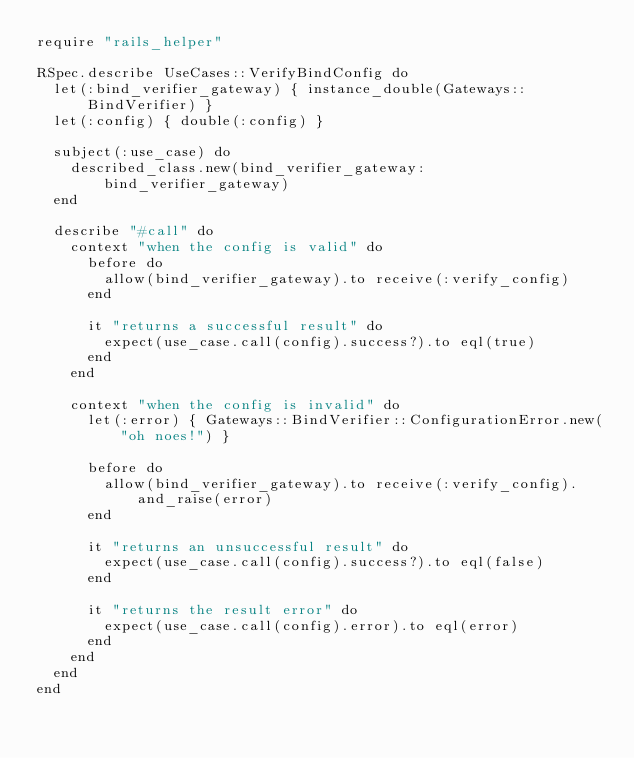<code> <loc_0><loc_0><loc_500><loc_500><_Ruby_>require "rails_helper"

RSpec.describe UseCases::VerifyBindConfig do
  let(:bind_verifier_gateway) { instance_double(Gateways::BindVerifier) }
  let(:config) { double(:config) }

  subject(:use_case) do
    described_class.new(bind_verifier_gateway: bind_verifier_gateway)
  end

  describe "#call" do
    context "when the config is valid" do
      before do
        allow(bind_verifier_gateway).to receive(:verify_config)
      end

      it "returns a successful result" do
        expect(use_case.call(config).success?).to eql(true)
      end
    end

    context "when the config is invalid" do
      let(:error) { Gateways::BindVerifier::ConfigurationError.new("oh noes!") }

      before do
        allow(bind_verifier_gateway).to receive(:verify_config).and_raise(error)
      end

      it "returns an unsuccessful result" do
        expect(use_case.call(config).success?).to eql(false)
      end

      it "returns the result error" do
        expect(use_case.call(config).error).to eql(error)
      end
    end
  end
end
</code> 